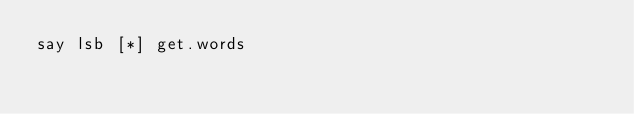<code> <loc_0><loc_0><loc_500><loc_500><_Perl_>say lsb [*] get.words</code> 